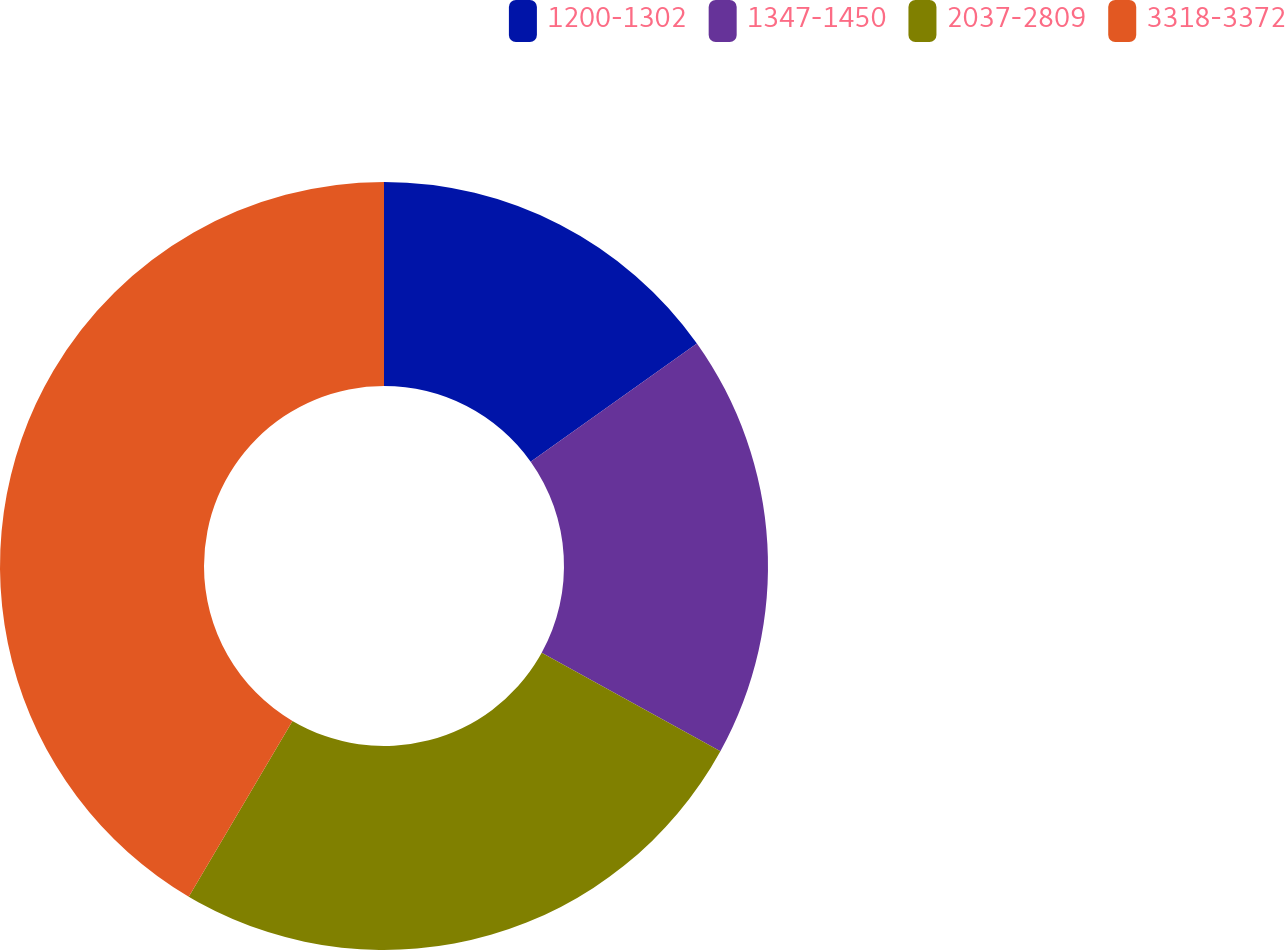Convert chart. <chart><loc_0><loc_0><loc_500><loc_500><pie_chart><fcel>1200-1302<fcel>1347-1450<fcel>2037-2809<fcel>3318-3372<nl><fcel>15.16%<fcel>17.85%<fcel>25.48%<fcel>41.51%<nl></chart> 